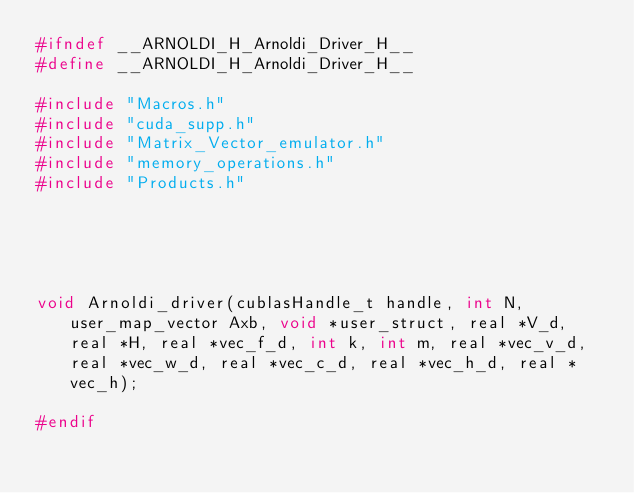<code> <loc_0><loc_0><loc_500><loc_500><_C_>#ifndef __ARNOLDI_H_Arnoldi_Driver_H__
#define __ARNOLDI_H_Arnoldi_Driver_H__

#include "Macros.h"
#include "cuda_supp.h"
#include "Matrix_Vector_emulator.h"
#include "memory_operations.h"
#include "Products.h"





void Arnoldi_driver(cublasHandle_t handle, int N, user_map_vector Axb, void *user_struct, real *V_d, real *H, real *vec_f_d, int k, int m, real *vec_v_d, real *vec_w_d, real *vec_c_d, real *vec_h_d, real *vec_h);

#endif</code> 